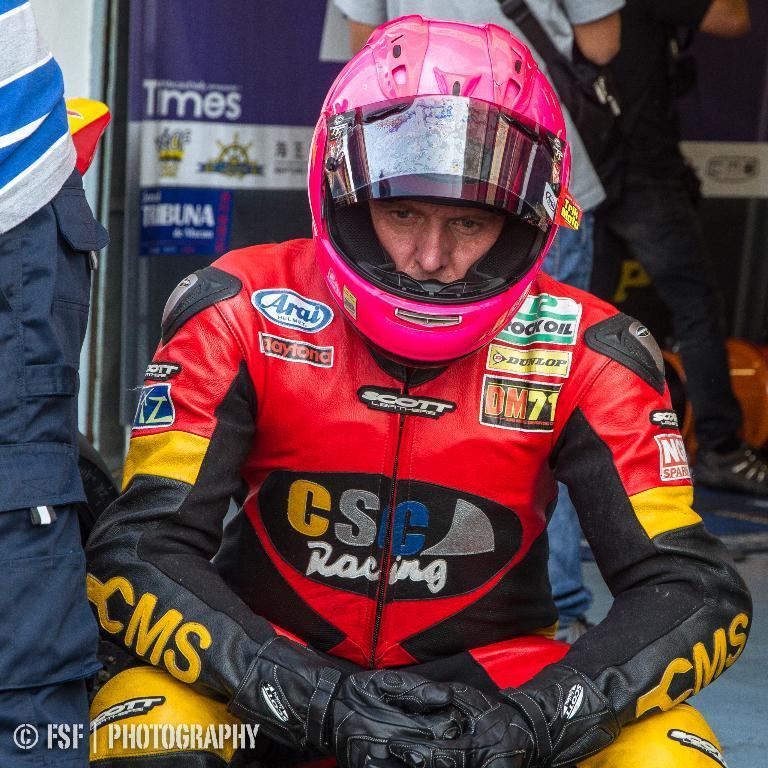Could you give a brief overview of what you see in this image? In this image we can see a person is wearing red, yellow and black color jacket with helmet and gloves. Background of the image, three persons and banners are there. At the left bottom of the image watermark is present. 